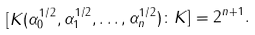Convert formula to latex. <formula><loc_0><loc_0><loc_500><loc_500>[ K ( \alpha _ { 0 } ^ { 1 / 2 } , \alpha _ { 1 } ^ { 1 / 2 } , \dots , \alpha _ { n } ^ { 1 / 2 } ) \colon K ] = 2 ^ { n + 1 } .</formula> 